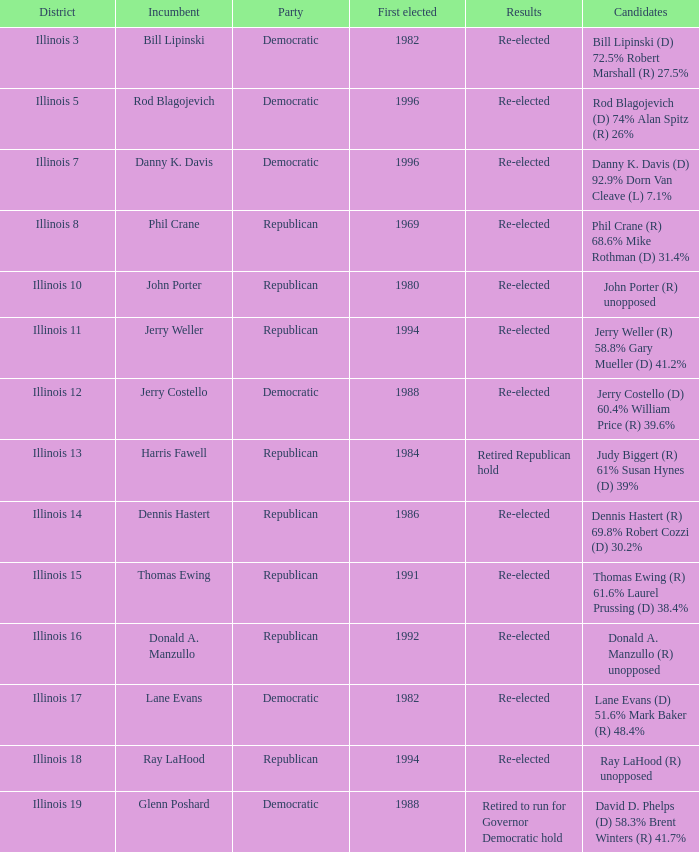Help me parse the entirety of this table. {'header': ['District', 'Incumbent', 'Party', 'First elected', 'Results', 'Candidates'], 'rows': [['Illinois 3', 'Bill Lipinski', 'Democratic', '1982', 'Re-elected', 'Bill Lipinski (D) 72.5% Robert Marshall (R) 27.5%'], ['Illinois 5', 'Rod Blagojevich', 'Democratic', '1996', 'Re-elected', 'Rod Blagojevich (D) 74% Alan Spitz (R) 26%'], ['Illinois 7', 'Danny K. Davis', 'Democratic', '1996', 'Re-elected', 'Danny K. Davis (D) 92.9% Dorn Van Cleave (L) 7.1%'], ['Illinois 8', 'Phil Crane', 'Republican', '1969', 'Re-elected', 'Phil Crane (R) 68.6% Mike Rothman (D) 31.4%'], ['Illinois 10', 'John Porter', 'Republican', '1980', 'Re-elected', 'John Porter (R) unopposed'], ['Illinois 11', 'Jerry Weller', 'Republican', '1994', 'Re-elected', 'Jerry Weller (R) 58.8% Gary Mueller (D) 41.2%'], ['Illinois 12', 'Jerry Costello', 'Democratic', '1988', 'Re-elected', 'Jerry Costello (D) 60.4% William Price (R) 39.6%'], ['Illinois 13', 'Harris Fawell', 'Republican', '1984', 'Retired Republican hold', 'Judy Biggert (R) 61% Susan Hynes (D) 39%'], ['Illinois 14', 'Dennis Hastert', 'Republican', '1986', 'Re-elected', 'Dennis Hastert (R) 69.8% Robert Cozzi (D) 30.2%'], ['Illinois 15', 'Thomas Ewing', 'Republican', '1991', 'Re-elected', 'Thomas Ewing (R) 61.6% Laurel Prussing (D) 38.4%'], ['Illinois 16', 'Donald A. Manzullo', 'Republican', '1992', 'Re-elected', 'Donald A. Manzullo (R) unopposed'], ['Illinois 17', 'Lane Evans', 'Democratic', '1982', 'Re-elected', 'Lane Evans (D) 51.6% Mark Baker (R) 48.4%'], ['Illinois 18', 'Ray LaHood', 'Republican', '1994', 'Re-elected', 'Ray LaHood (R) unopposed'], ['Illinois 19', 'Glenn Poshard', 'Democratic', '1988', 'Retired to run for Governor Democratic hold', 'David D. Phelps (D) 58.3% Brent Winters (R) 41.7%']]} What was the result in Illinois 7? Re-elected. 